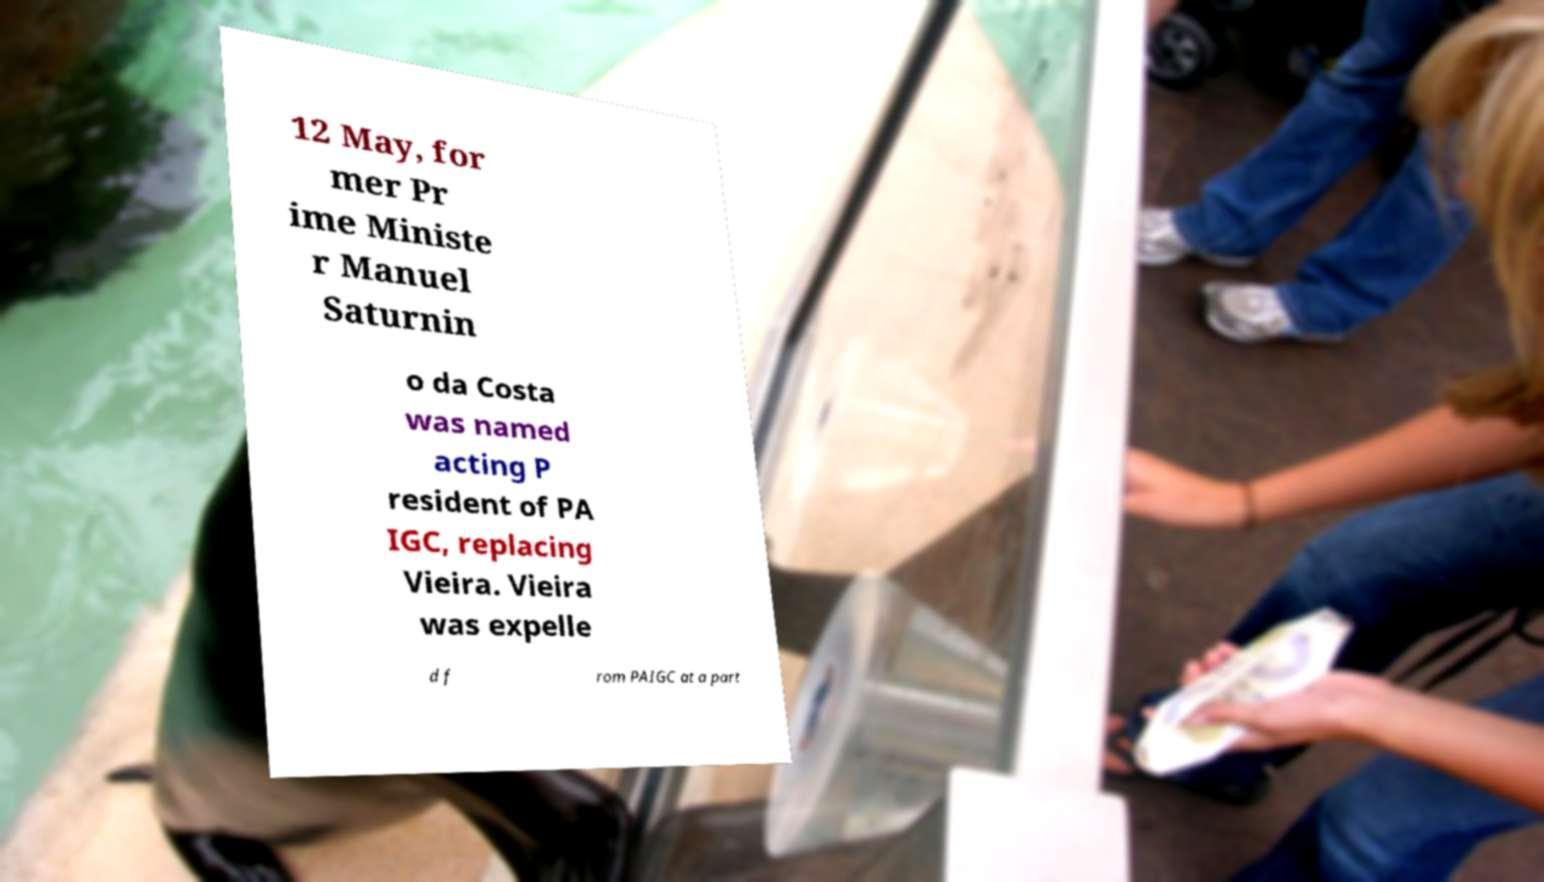What messages or text are displayed in this image? I need them in a readable, typed format. 12 May, for mer Pr ime Ministe r Manuel Saturnin o da Costa was named acting P resident of PA IGC, replacing Vieira. Vieira was expelle d f rom PAIGC at a part 